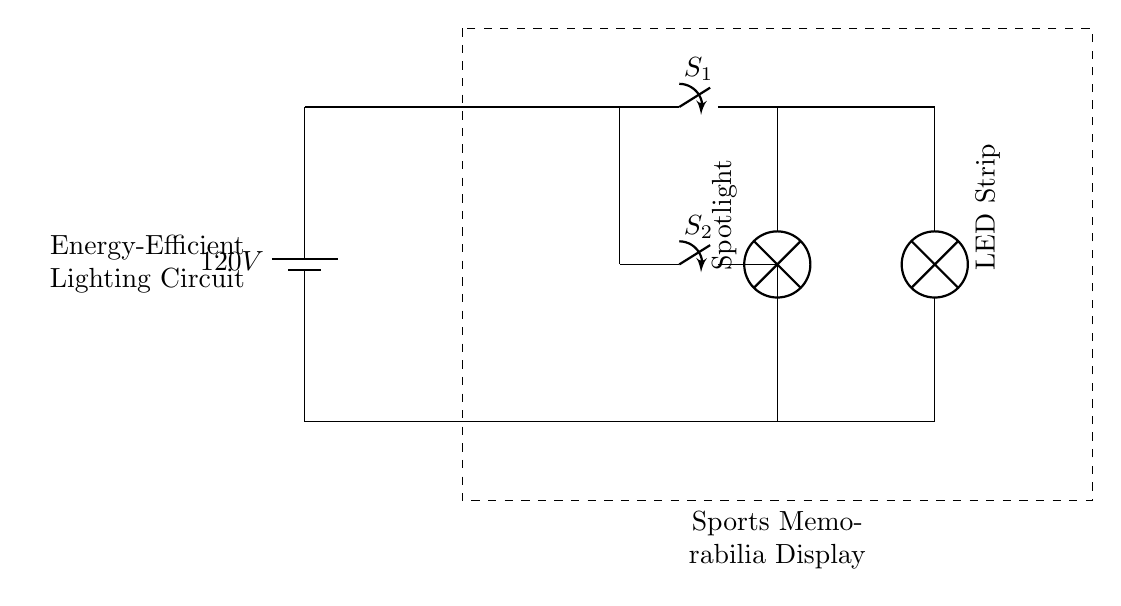What is the voltage of this circuit? The voltage is 120V, which is indicated by the battery symbol labeled $120V$ in the diagram.
Answer: 120V What type of lamp is used in this circuit? There are two types of lamps in this circuit: an LED Strip and a Spotlight, each represented with different labels on the circuit diagram.
Answer: LED Strip and Spotlight How many switches are there in this circuit? There are two switches in the diagram, labeled as $S_1$ and $S_2$. These switches control the connection to the lamp circuits.
Answer: 2 What is the purpose of the dashed rectangle in the diagram? The dashed rectangle highlights the section of the circuit dedicated to the Sports Memorabilia Display, indicating that it is a designated area for lighting, as specified in the labeling.
Answer: Sports Memorabilia Display Which switch controls the LED Strip? Switch $S_1$ controls the LED Strip, as it is connected directly to the LED Strip lamp and not to any other component in the circuit.
Answer: S1 If both switches are closed, what is the state of the lamps? If both switches are closed, both the LED Strip and the Spotlight will be turned on since the current will flow through both switches to their respective lamps.
Answer: On Which lamp is positioned lower in the circuit diagram? The Spotlight is positioned lower in the diagram, as indicated by its placement at (6,0), while the LED Strip is positioned at (8,0).
Answer: Spotlight 